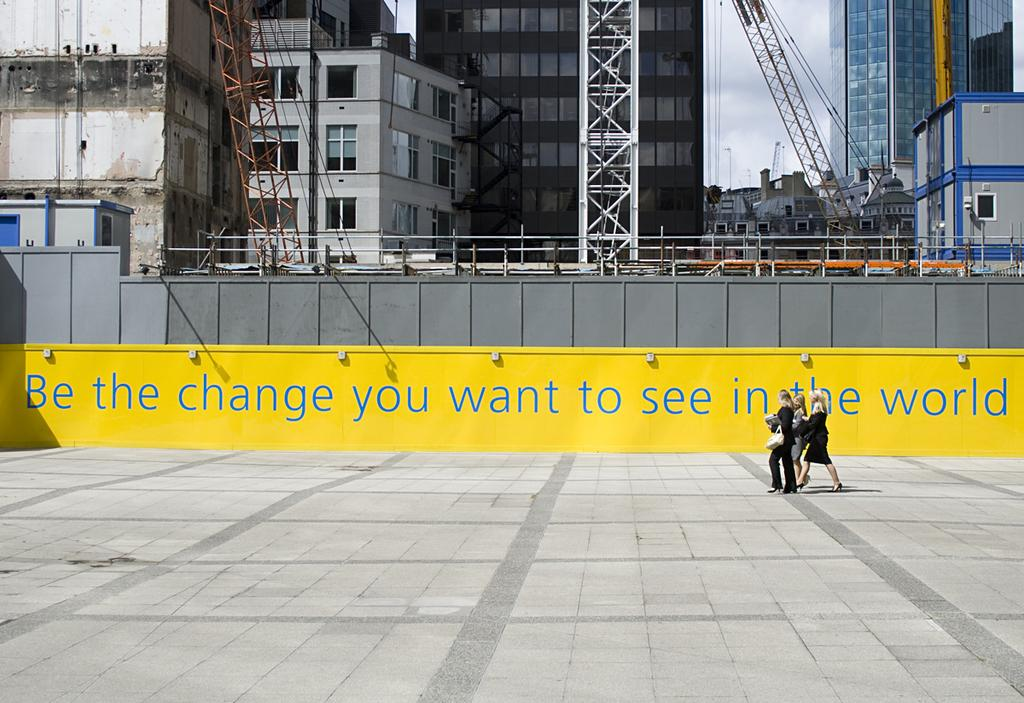What are the people in the foreground of the image doing? The people in the foreground of the image are walking. What can be seen in the background of the image? There are buildings, a boundary or structure, towers, and the sky visible in the background of the image. What type of teeth can be seen in the image? There are no teeth visible in the image. How does the cough affect the people walking in the image? There is no mention of a cough in the image, so it cannot affect the people walking. 